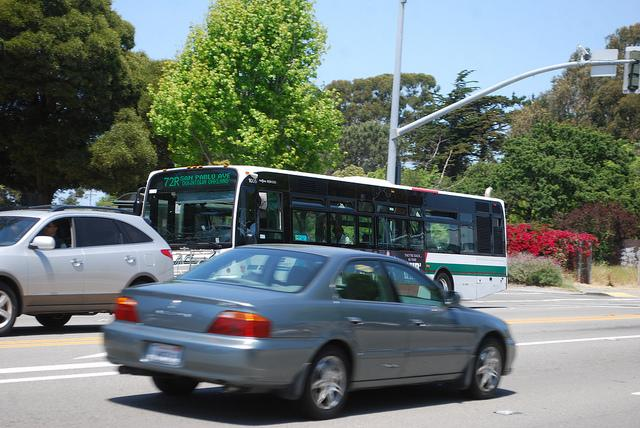How many directions are the vehicles shown going in?

Choices:
A) seven
B) one
C) three
D) two two 